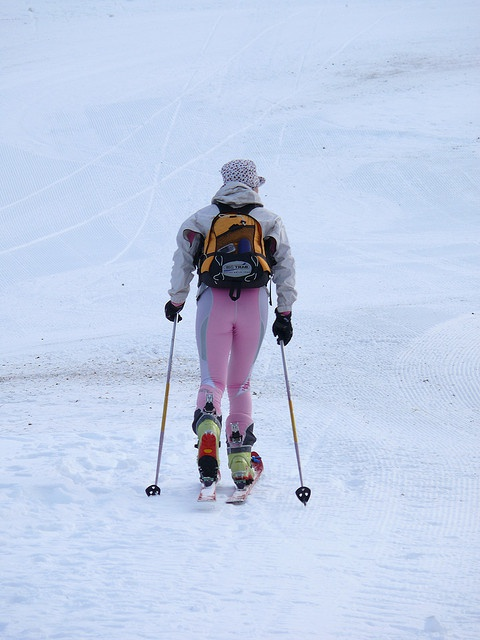Describe the objects in this image and their specific colors. I can see people in lavender, black, violet, darkgray, and gray tones, backpack in lavender, black, olive, maroon, and gray tones, and skis in lavender, darkgray, and gray tones in this image. 